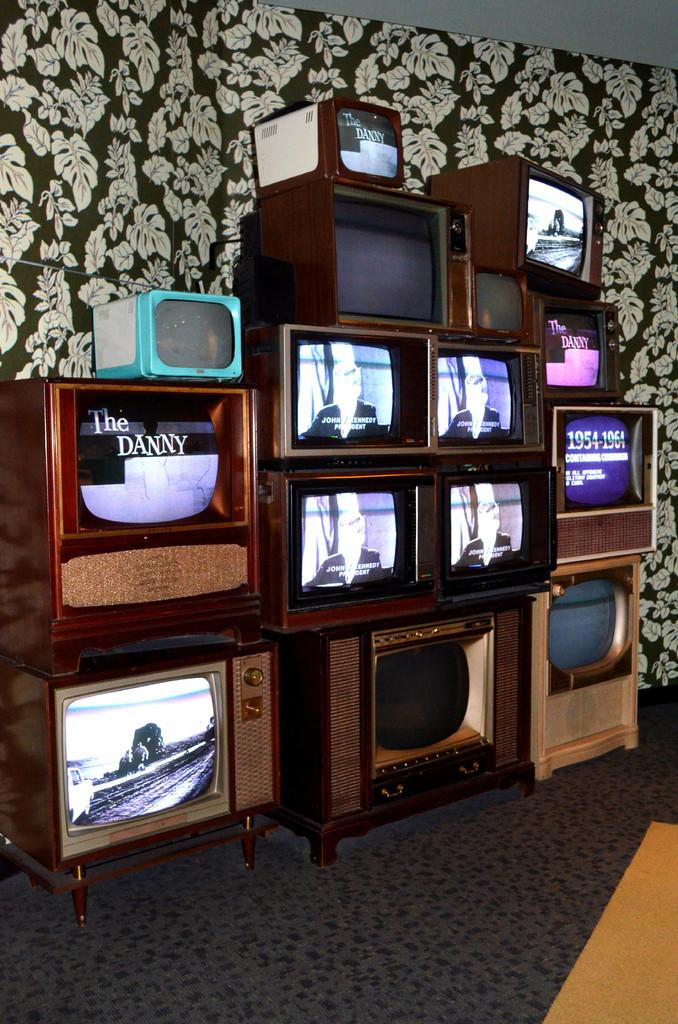What is the main subject in the middle of the image? There are televisions in the middle of the image. What can be seen in the background of the image? There is a flower design curtain in the background. What part of the room is visible at the bottom of the image? The floor is visible at the bottom of the image. What type of noise can be heard coming from the birth in the image? There is no birth or noise present in the image; it features televisions and a flower design curtain. 